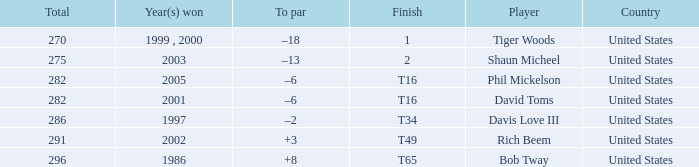In what place did Phil Mickelson finish with a total of 282? T16. 